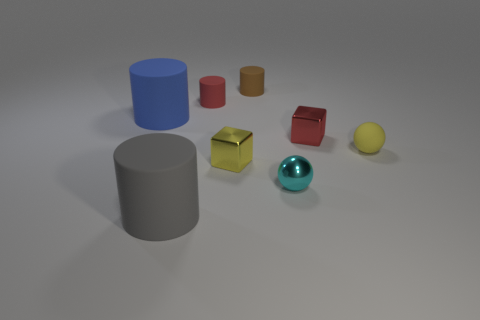How many brown things are either big objects or metallic blocks? In the image, there are three brown items that qualify as either big objects or metallic blocks. One is a large brown cylinder, and the other two are smaller yet sizable metallic brown cylinders. 